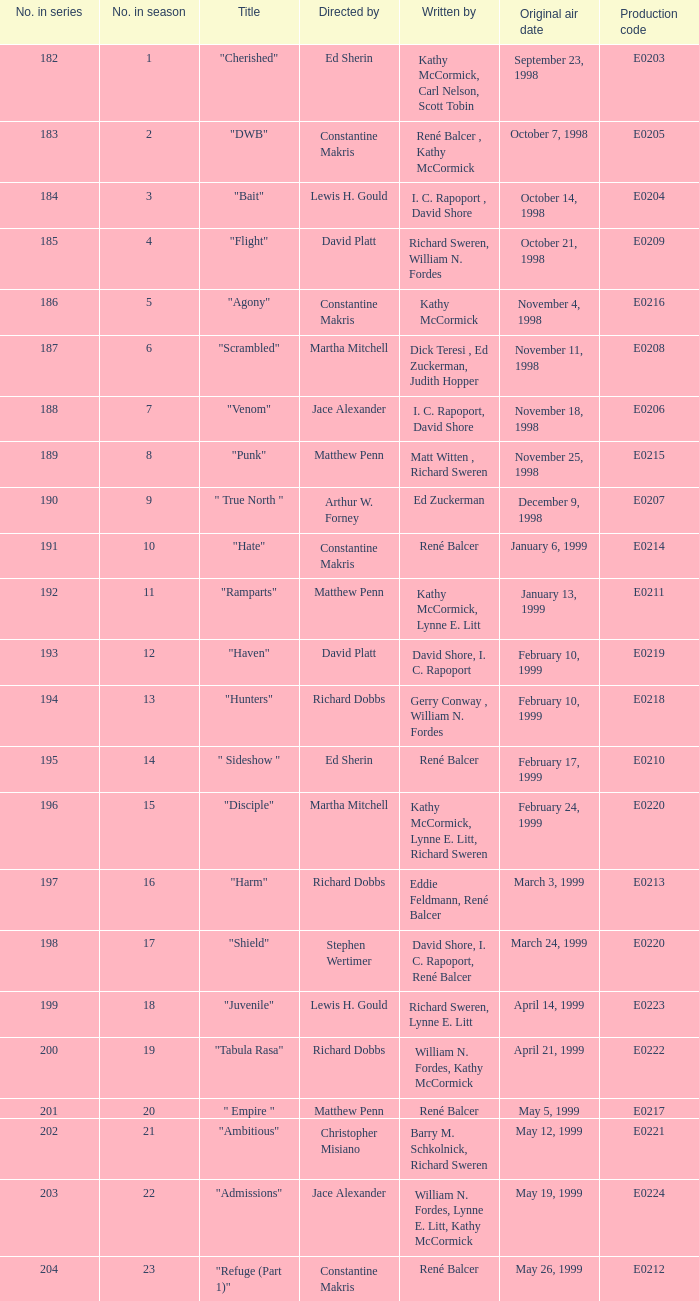The episode with the original air date January 6, 1999, has what production code? E0214. 